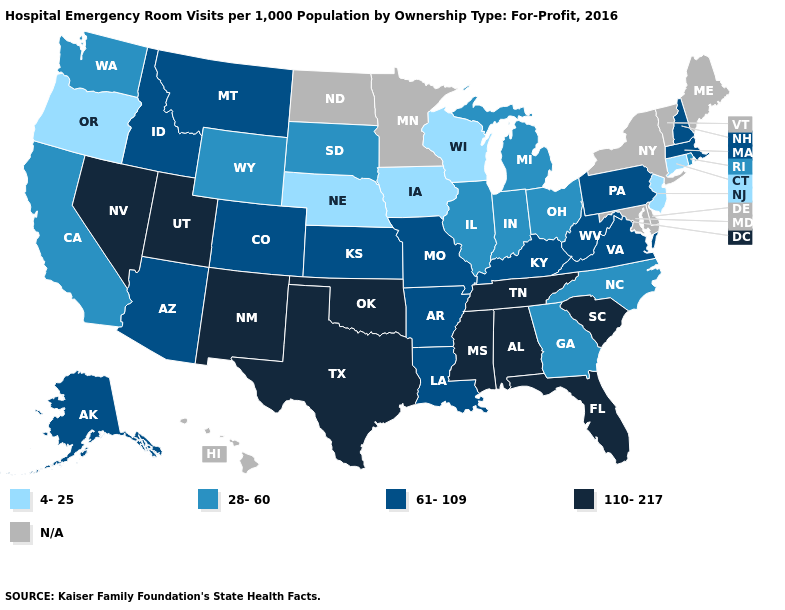What is the lowest value in the South?
Keep it brief. 28-60. How many symbols are there in the legend?
Concise answer only. 5. Name the states that have a value in the range 61-109?
Keep it brief. Alaska, Arizona, Arkansas, Colorado, Idaho, Kansas, Kentucky, Louisiana, Massachusetts, Missouri, Montana, New Hampshire, Pennsylvania, Virginia, West Virginia. Among the states that border Missouri , which have the lowest value?
Write a very short answer. Iowa, Nebraska. Does Pennsylvania have the highest value in the Northeast?
Concise answer only. Yes. What is the value of California?
Write a very short answer. 28-60. Is the legend a continuous bar?
Quick response, please. No. Name the states that have a value in the range N/A?
Concise answer only. Delaware, Hawaii, Maine, Maryland, Minnesota, New York, North Dakota, Vermont. What is the highest value in the USA?
Concise answer only. 110-217. Name the states that have a value in the range 61-109?
Short answer required. Alaska, Arizona, Arkansas, Colorado, Idaho, Kansas, Kentucky, Louisiana, Massachusetts, Missouri, Montana, New Hampshire, Pennsylvania, Virginia, West Virginia. Name the states that have a value in the range 110-217?
Answer briefly. Alabama, Florida, Mississippi, Nevada, New Mexico, Oklahoma, South Carolina, Tennessee, Texas, Utah. Name the states that have a value in the range N/A?
Keep it brief. Delaware, Hawaii, Maine, Maryland, Minnesota, New York, North Dakota, Vermont. Does New Mexico have the highest value in the USA?
Answer briefly. Yes. What is the lowest value in states that border New Hampshire?
Write a very short answer. 61-109. 